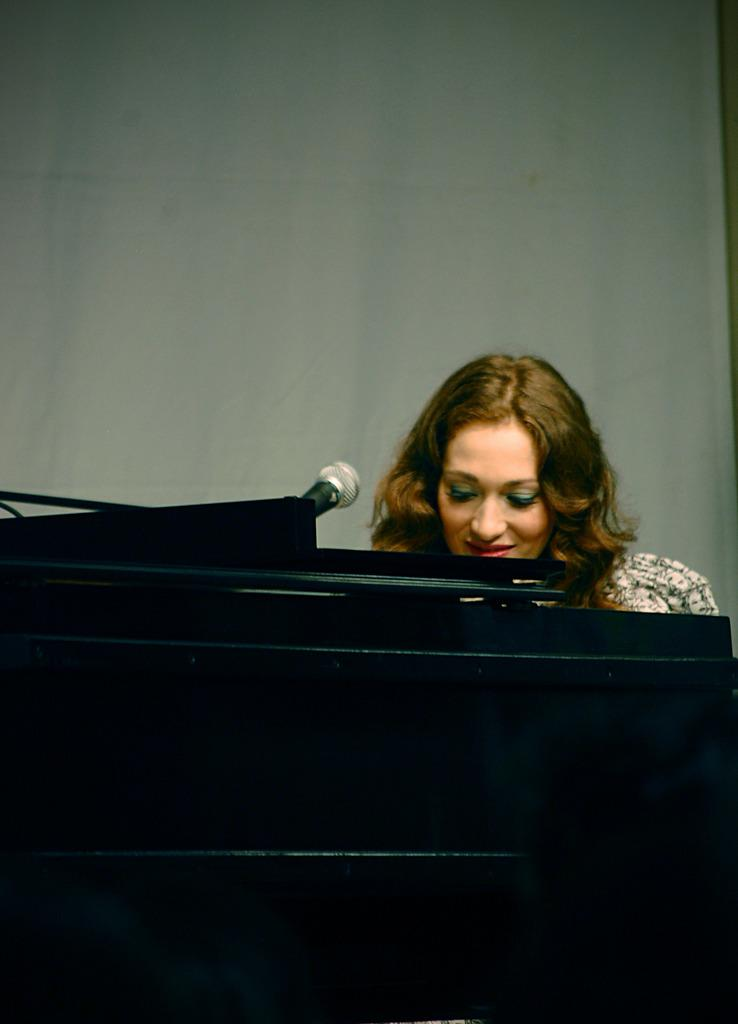Who is the main subject in the image? There is a woman in the image. What object is in front of the woman? There is a microphone in front of the woman. What color is the wall behind the woman? There is a white-colored wall behind the woman. How many hours does the thread on the woman's dress have? There is no thread mentioned or visible on the woman's dress in the image. 